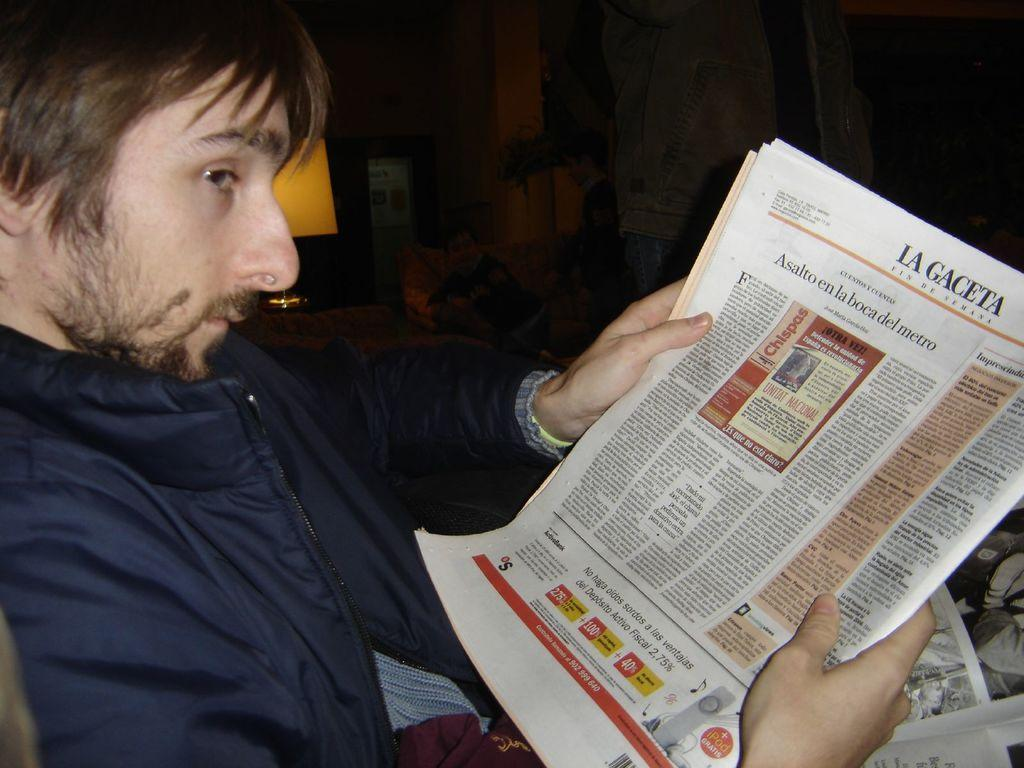Who is present in the image? There is a man in the image. What is the man doing in the image? The man is sitting in the image. What is the man holding in his hands? The man is holding a newspaper in his hands. What can be seen in the background of the image? There is a light in the background of the image. What type of country is being sold at the market in the image? There is no market or country present in the image; it features a man sitting and holding a newspaper. What type of beam is supporting the ceiling in the image? There is no visible ceiling or beam in the image. 